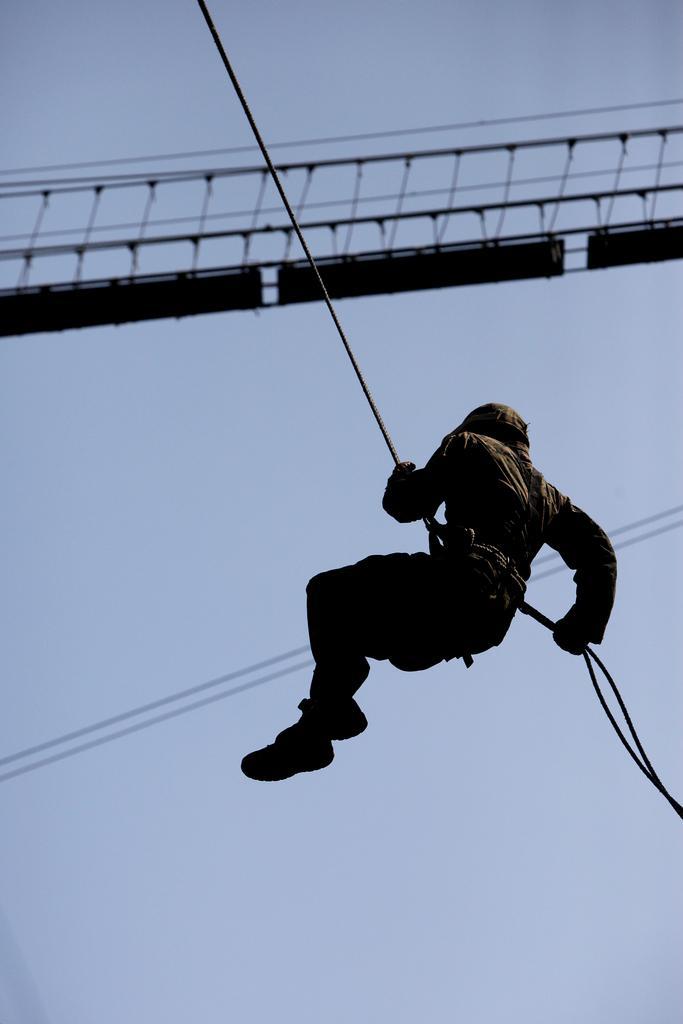Could you give a brief overview of what you see in this image? In this picture I can see a person hanging with a rope, there are cables, there is a wooden bridge, and in the background there is the sky. 